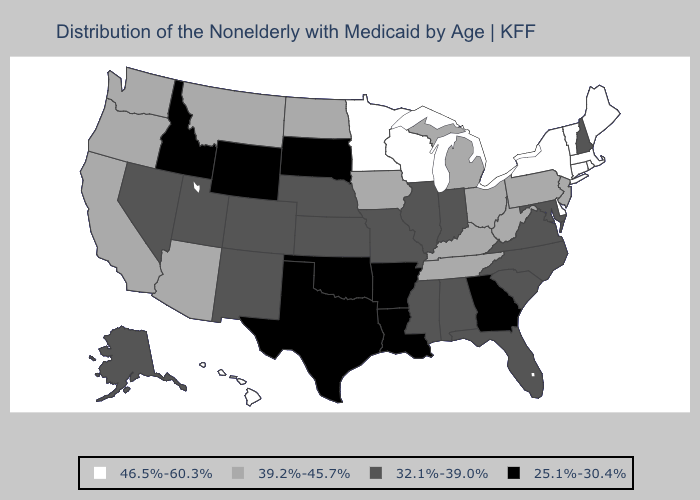Name the states that have a value in the range 46.5%-60.3%?
Answer briefly. Connecticut, Delaware, Hawaii, Maine, Massachusetts, Minnesota, New York, Rhode Island, Vermont, Wisconsin. Which states have the highest value in the USA?
Be succinct. Connecticut, Delaware, Hawaii, Maine, Massachusetts, Minnesota, New York, Rhode Island, Vermont, Wisconsin. Among the states that border Wyoming , does Nebraska have the lowest value?
Keep it brief. No. What is the lowest value in the MidWest?
Concise answer only. 25.1%-30.4%. Name the states that have a value in the range 39.2%-45.7%?
Be succinct. Arizona, California, Iowa, Kentucky, Michigan, Montana, New Jersey, North Dakota, Ohio, Oregon, Pennsylvania, Tennessee, Washington, West Virginia. Among the states that border New York , does Massachusetts have the highest value?
Give a very brief answer. Yes. Name the states that have a value in the range 32.1%-39.0%?
Give a very brief answer. Alabama, Alaska, Colorado, Florida, Illinois, Indiana, Kansas, Maryland, Mississippi, Missouri, Nebraska, Nevada, New Hampshire, New Mexico, North Carolina, South Carolina, Utah, Virginia. Does Nevada have the lowest value in the West?
Keep it brief. No. Does South Dakota have the lowest value in the MidWest?
Short answer required. Yes. What is the value of Indiana?
Keep it brief. 32.1%-39.0%. Name the states that have a value in the range 25.1%-30.4%?
Keep it brief. Arkansas, Georgia, Idaho, Louisiana, Oklahoma, South Dakota, Texas, Wyoming. What is the highest value in the South ?
Be succinct. 46.5%-60.3%. What is the value of Ohio?
Give a very brief answer. 39.2%-45.7%. What is the lowest value in the MidWest?
Be succinct. 25.1%-30.4%. 